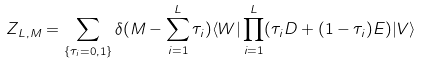<formula> <loc_0><loc_0><loc_500><loc_500>Z _ { L , M } = \sum _ { \{ \tau _ { i } = 0 , 1 \} } \delta ( M - \sum _ { i = 1 } ^ { L } \tau _ { i } ) \langle W | \prod _ { i = 1 } ^ { L } ( \tau _ { i } D + ( 1 - \tau _ { i } ) E ) | V \rangle</formula> 